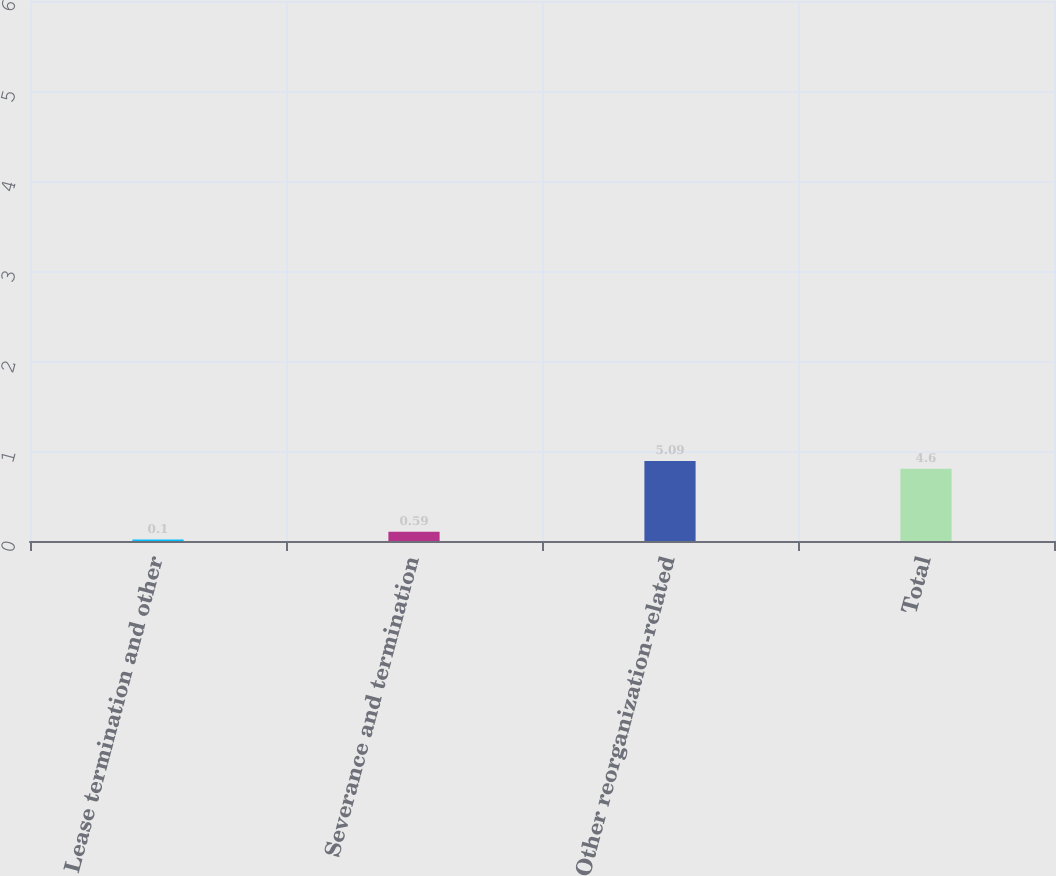Convert chart. <chart><loc_0><loc_0><loc_500><loc_500><bar_chart><fcel>Lease termination and other<fcel>Severance and termination<fcel>Other reorganization-related<fcel>Total<nl><fcel>0.1<fcel>0.59<fcel>5.09<fcel>4.6<nl></chart> 